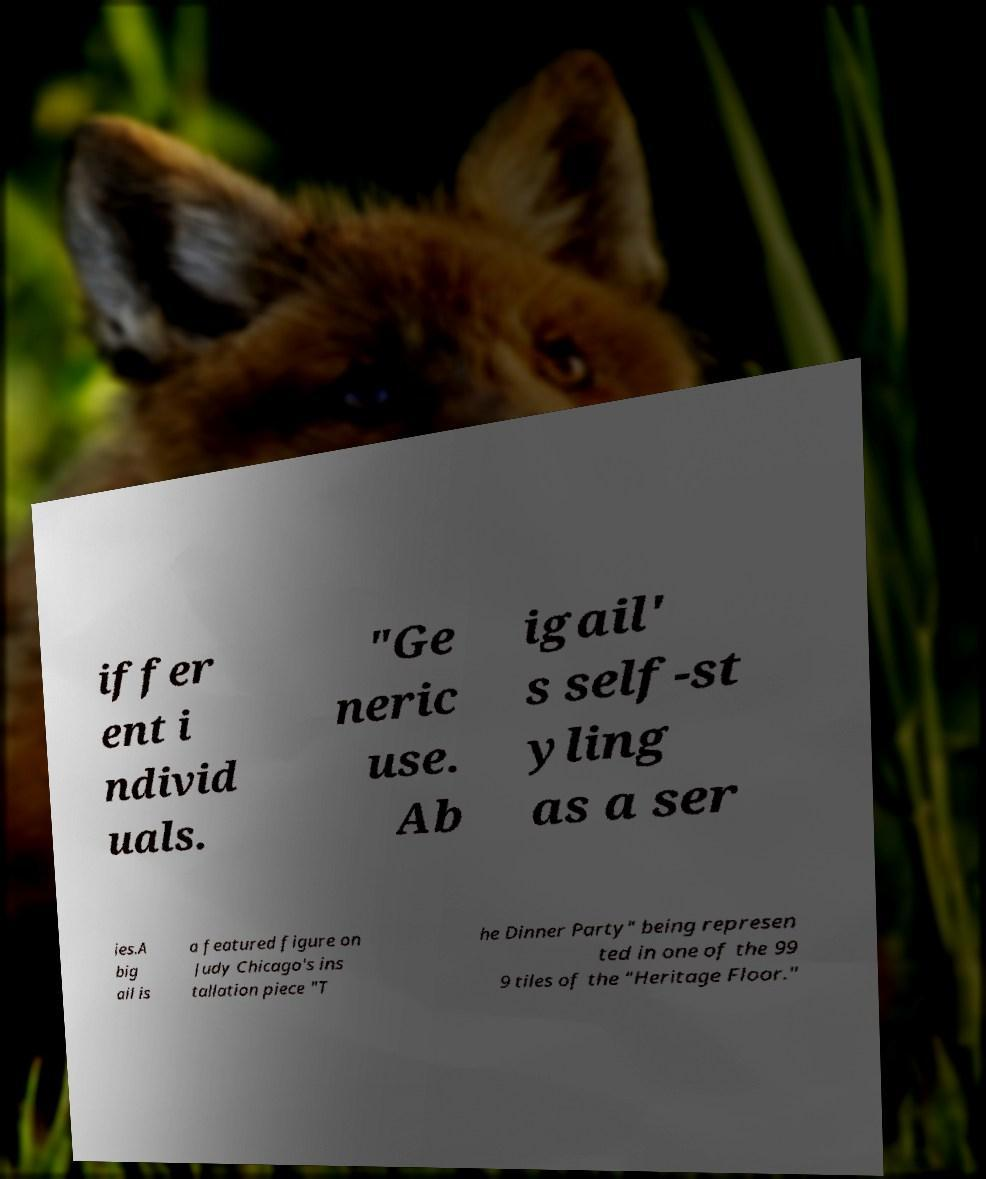Can you read and provide the text displayed in the image?This photo seems to have some interesting text. Can you extract and type it out for me? iffer ent i ndivid uals. "Ge neric use. Ab igail' s self-st yling as a ser ies.A big ail is a featured figure on Judy Chicago's ins tallation piece "T he Dinner Party" being represen ted in one of the 99 9 tiles of the "Heritage Floor." 